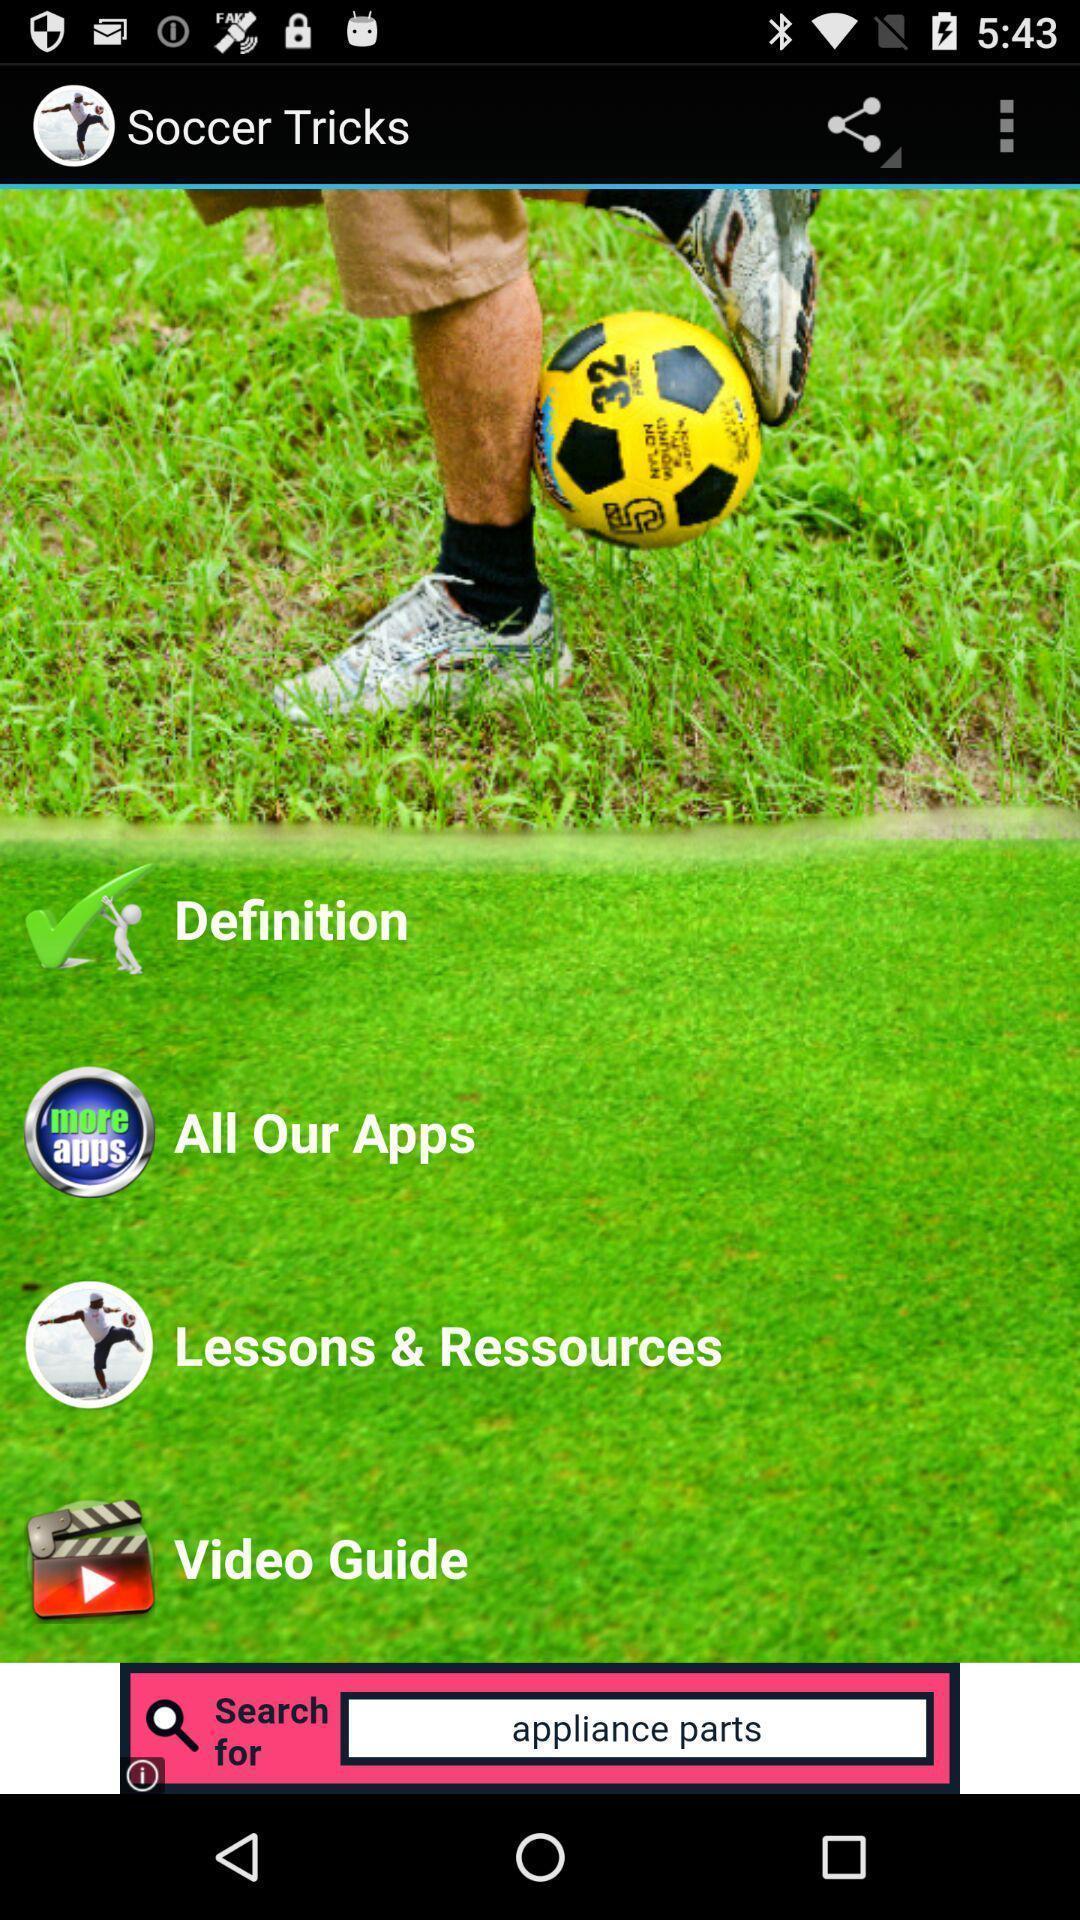Tell me what you see in this picture. Page showing about different options in app. 